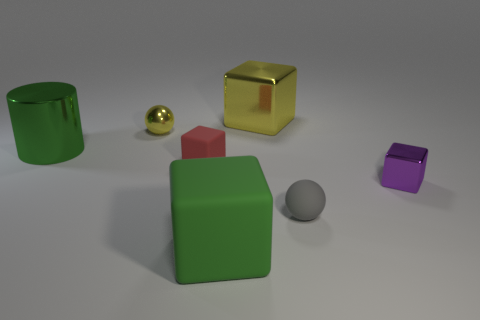What number of objects are big cyan matte spheres or yellow metallic objects? In the image, there is one big cyan matte sphere and one yellow metallic cube, making a total of two objects that fit the criteria. 